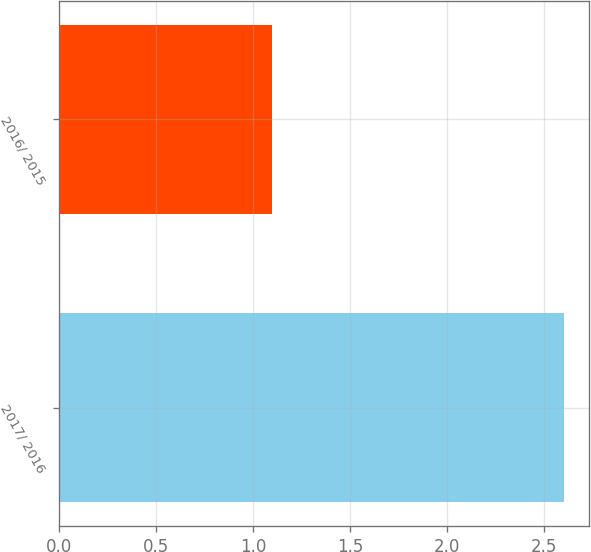Convert chart to OTSL. <chart><loc_0><loc_0><loc_500><loc_500><bar_chart><fcel>2017/ 2016<fcel>2016/ 2015<nl><fcel>2.6<fcel>1.1<nl></chart> 